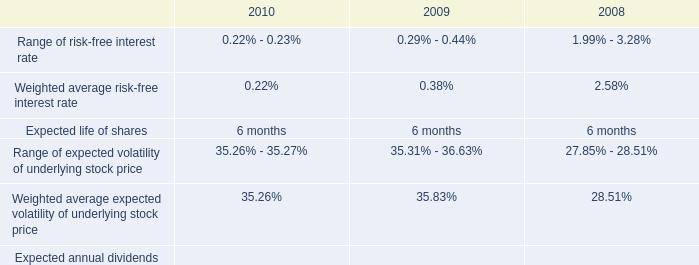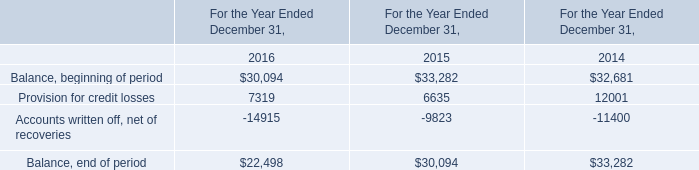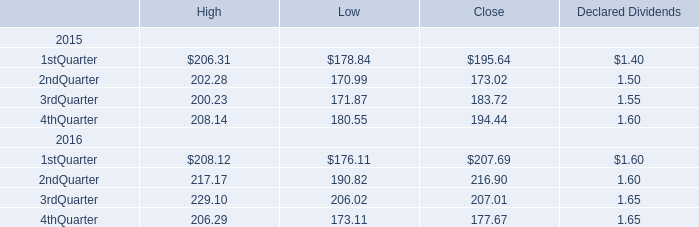What was the average value of the 3rdQuarter in the years where 1stQuarter is positive? 
Computations: ((((((((200.23 + 171.87) + 183.72) + 1.55) + 229.10) + 206.02) + 207.01) + 1.65) / 2)
Answer: 600.575. 